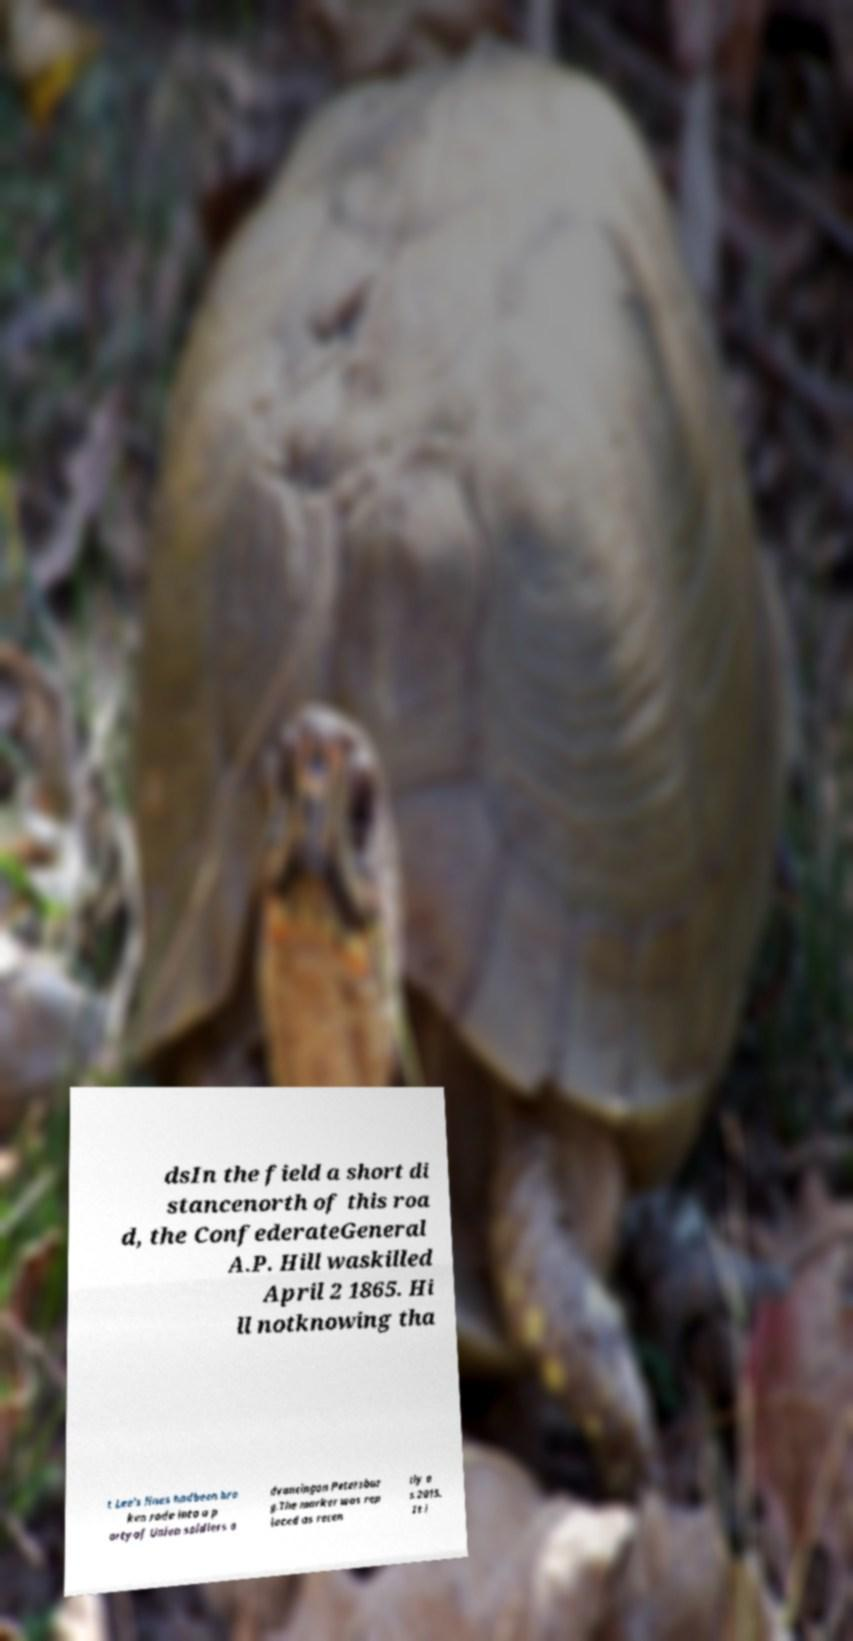There's text embedded in this image that I need extracted. Can you transcribe it verbatim? dsIn the field a short di stancenorth of this roa d, the ConfederateGeneral A.P. Hill waskilled April 2 1865. Hi ll notknowing tha t Lee's lines hadbeen bro ken rode into a p artyof Union soldiers a dvancingon Petersbur g.The marker was rep laced as recen tly a s 2015. It i 